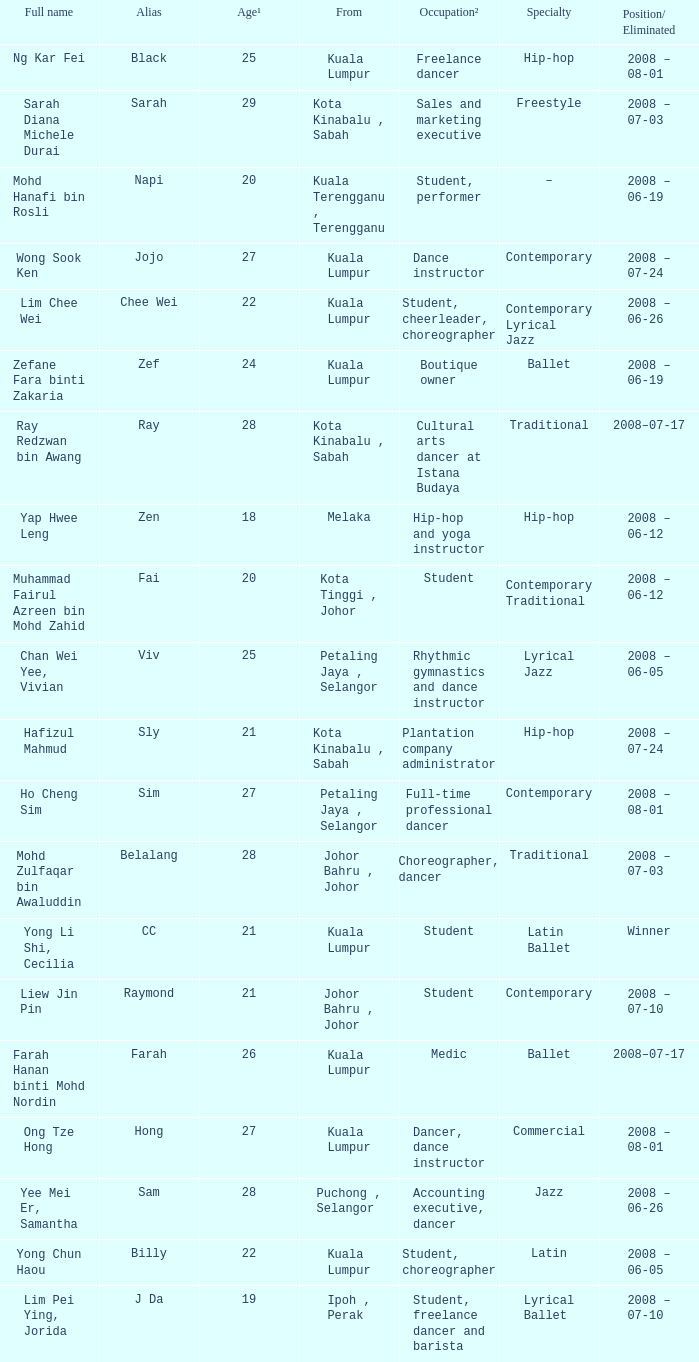What is the place/ excluded, when starting point is "kuala lumpur", and when specialization is "contemporary lyrical jazz"? 2008 – 06-26. 